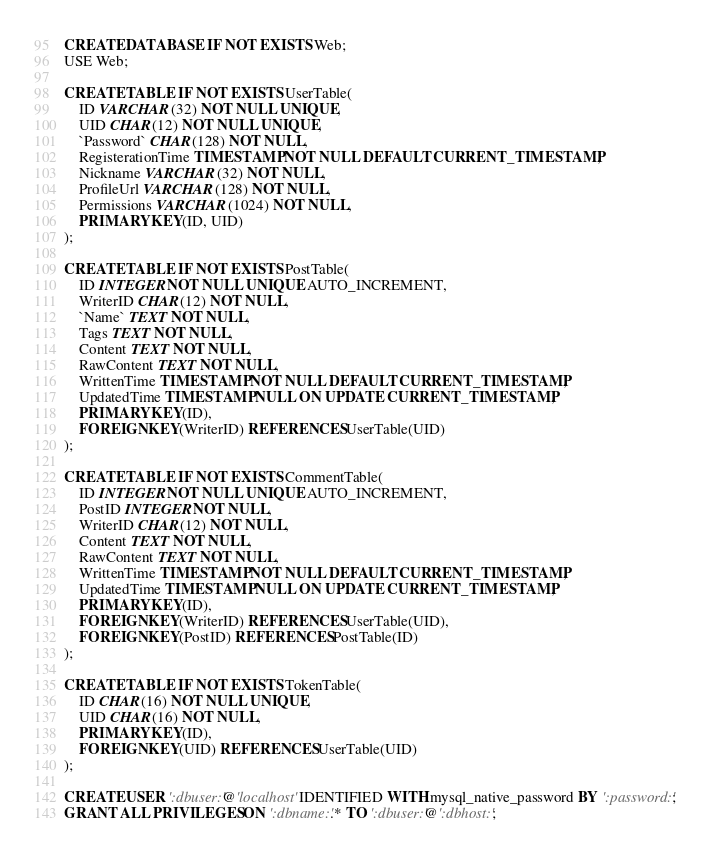<code> <loc_0><loc_0><loc_500><loc_500><_SQL_>CREATE DATABASE IF NOT EXISTS Web;
USE Web;

CREATE TABLE IF NOT EXISTS UserTable(
	ID VARCHAR(32) NOT NULL UNIQUE,
    UID CHAR(12) NOT NULL UNIQUE,
    `Password` CHAR(128) NOT NULL,
    RegisterationTime TIMESTAMP NOT NULL DEFAULT CURRENT_TIMESTAMP,
    Nickname VARCHAR(32) NOT NULL,
    ProfileUrl VARCHAR(128) NOT NULL,
    Permissions VARCHAR(1024) NOT NULL,
    PRIMARY KEY(ID, UID)
);

CREATE TABLE IF NOT EXISTS PostTable(
	ID INTEGER NOT NULL UNIQUE AUTO_INCREMENT,
    WriterID CHAR(12) NOT NULL,
    `Name` TEXT NOT NULL,
    Tags TEXT NOT NULL,
    Content TEXT NOT NULL,
    RawContent TEXT NOT NULL,
    WrittenTime TIMESTAMP NOT NULL DEFAULT CURRENT_TIMESTAMP,
    UpdatedTime TIMESTAMP NULL ON UPDATE CURRENT_TIMESTAMP,
    PRIMARY KEY(ID),
    FOREIGN KEY(WriterID) REFERENCES UserTable(UID)
);

CREATE TABLE IF NOT EXISTS CommentTable(
	ID INTEGER NOT NULL UNIQUE AUTO_INCREMENT,
    PostID INTEGER NOT NULL,
    WriterID CHAR(12) NOT NULL,
    Content TEXT NOT NULL,
    RawContent TEXT NOT NULL,
    WrittenTime TIMESTAMP NOT NULL DEFAULT CURRENT_TIMESTAMP,
    UpdatedTime TIMESTAMP NULL ON UPDATE CURRENT_TIMESTAMP,
    PRIMARY KEY(ID),
    FOREIGN KEY(WriterID) REFERENCES UserTable(UID),
    FOREIGN KEY(PostID) REFERENCES PostTable(ID)
);

CREATE TABLE IF NOT EXISTS TokenTable(
    ID CHAR(16) NOT NULL UNIQUE,
    UID CHAR(16) NOT NULL,
    PRIMARY KEY(ID),
    FOREIGN KEY(UID) REFERENCES UserTable(UID)
);

CREATE USER ':dbuser:'@'localhost' IDENTIFIED WITH mysql_native_password BY ':password:';
GRANT ALL PRIVILEGES ON ':dbname:'.* TO ':dbuser:'@':dbhost:';</code> 